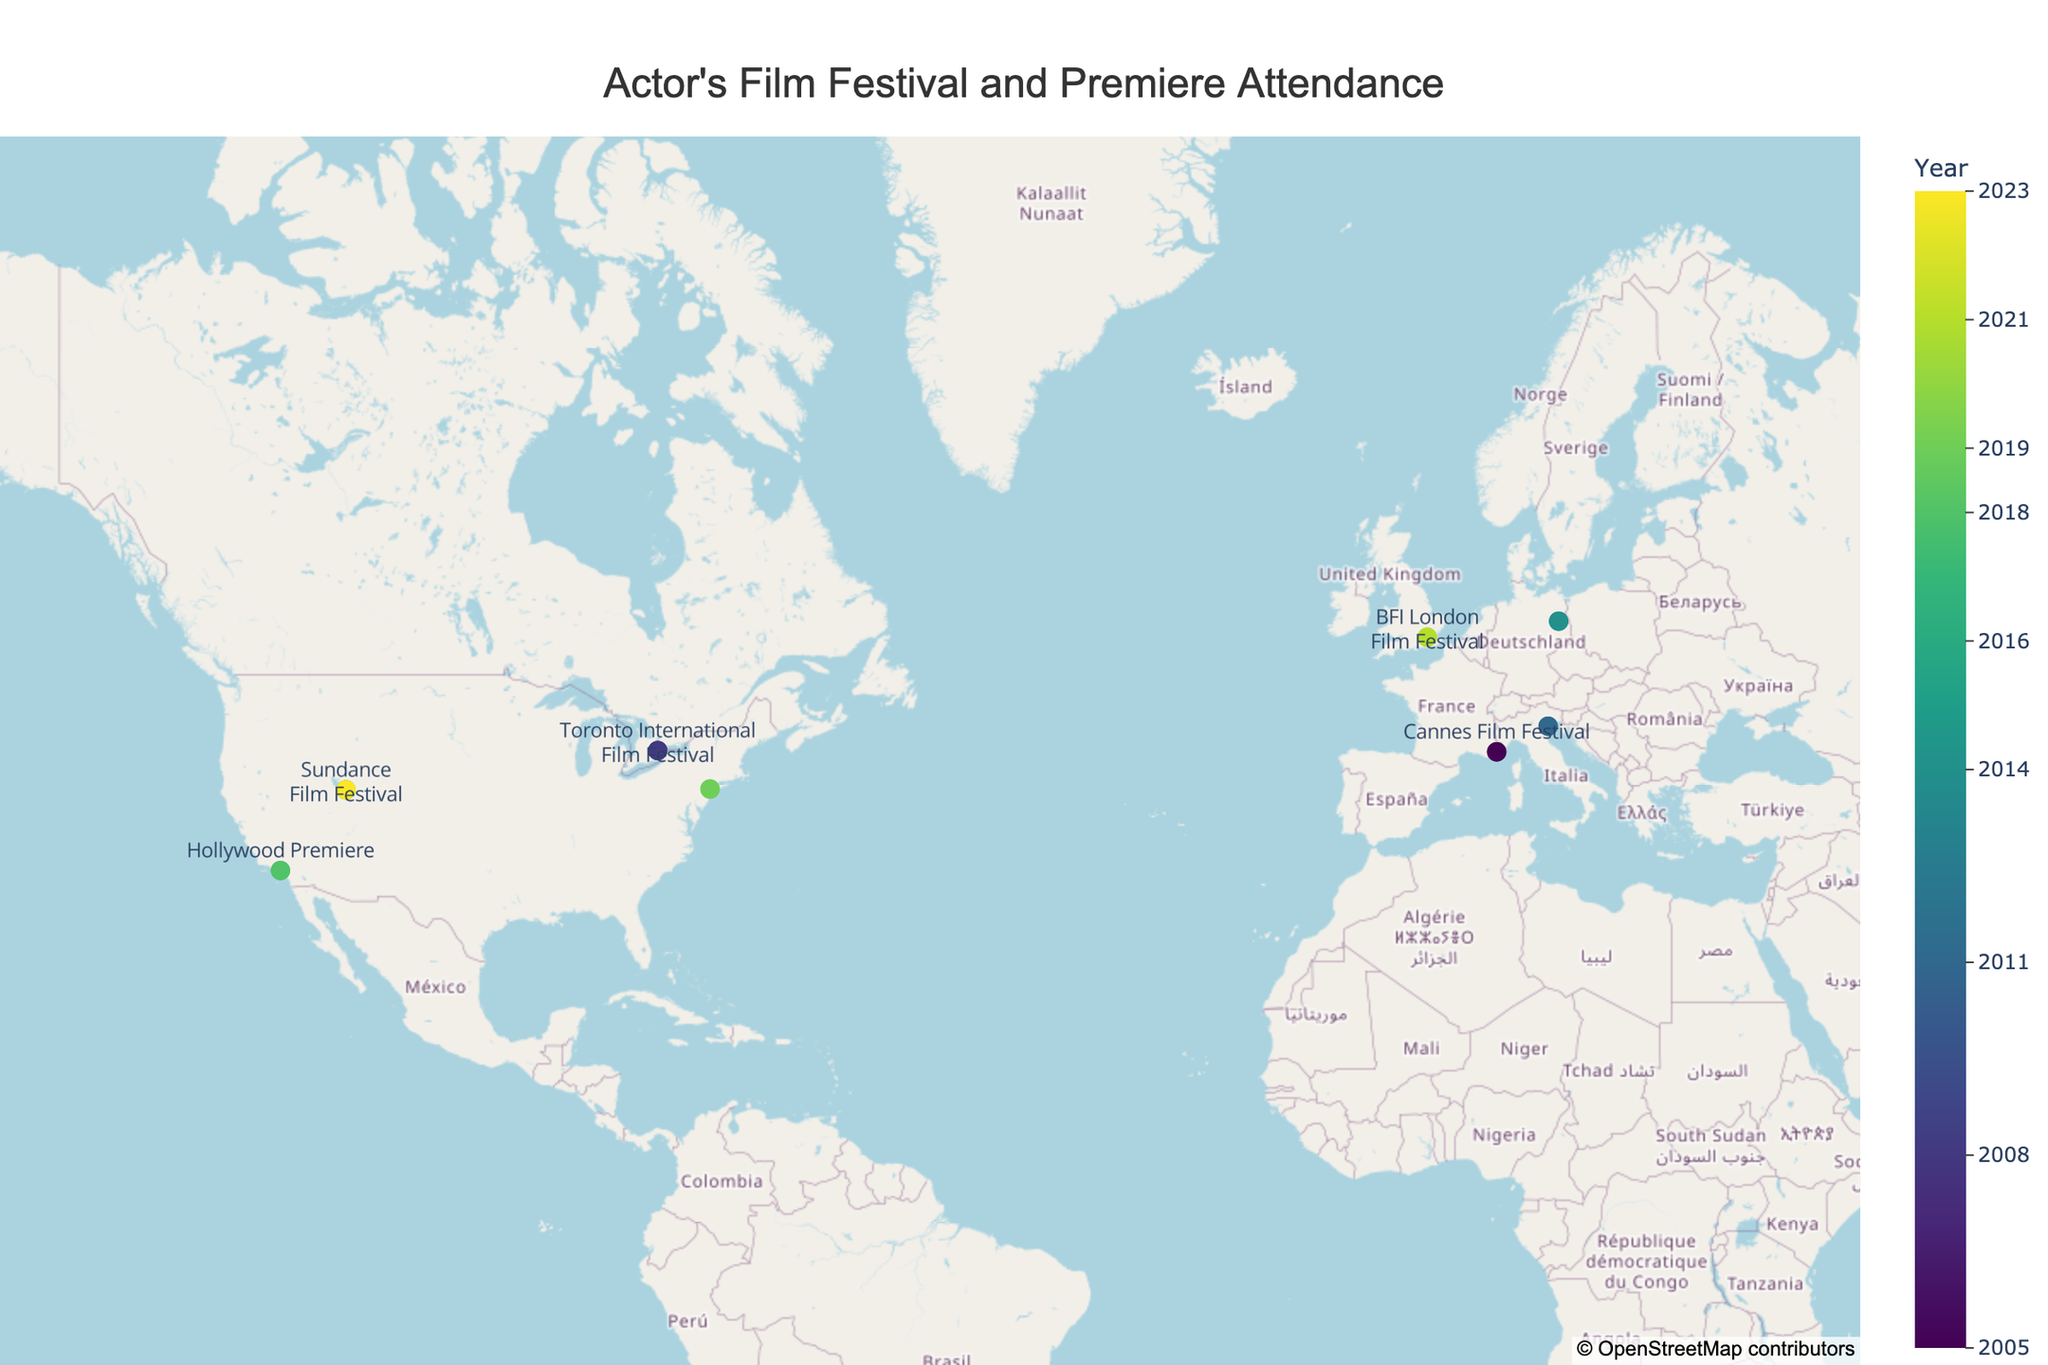What's the title of the figure? The title of the figure is located at the top and is typically larger and bolder than other text elements.
Answer: Actor's Film Festival and Premiere Attendance How many film festival and premiere locations are marked on the map? Count the number of markers on the map, each representing a different location attended by the actor.
Answer: 9 Which event did the actor attend in 2018? Find the marker corresponding to the year 2018 and refer to its label/text.
Answer: Hollywood Premiere What is the latitude and longitude of the Cannes Film Festival? Locate the marker for Cannes Film Festival and find its corresponding coordinates (latitude and longitude).
Answer: 43.5528, 7.0174 Which locations did the actor visit more than once for events? Count the occurrences of each location and identify any location mentioned more than once.
Answer: Sundance (Park City, 2016 and 2023) In which year did the actor attend the Berlin International Film Festival? Locate the marker labeled "Berlin International Film Festival" and read the associated year.
Answer: 2014 Which event is located furthest north? Identify the marker with the highest latitude value.
Answer: Berlin International Film Festival Compare the latitude values of the Venice and Cannes Film Festivals. Which one is further north? Venice is located at latitude 45.4408, while Cannes is at latitude 43.5528. Compare the latitudes to determine which is higher.
Answer: Venice How many events did the actor attend in North America? Count the number of markers located in North America (latitude and longitude within the geographic boundaries of North America).
Answer: 5 (Toronto, Sundance (2), Los Angeles, New York City) What is the median year of events attended by the actor? List all the event years, sort them, and find the median value (middle value in the sorted list). Given the sorted years (2005, 2008, 2011, 2014, 2016, 2018, 2019, 2021, 2023), the median is the 5th value.
Answer: 2016 